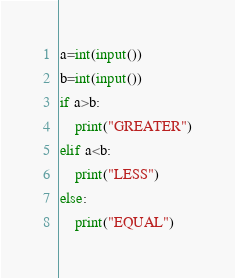<code> <loc_0><loc_0><loc_500><loc_500><_Python_>a=int(input())
b=int(input())
if a>b:
    print("GREATER")
elif a<b:
    print("LESS")
else:
    print("EQUAL")</code> 